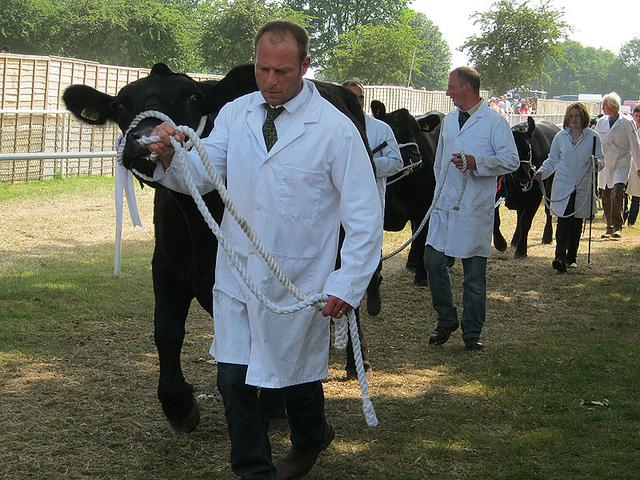Who are these grownups? Please explain your reasoning. medical workers. The men are wearing white. 